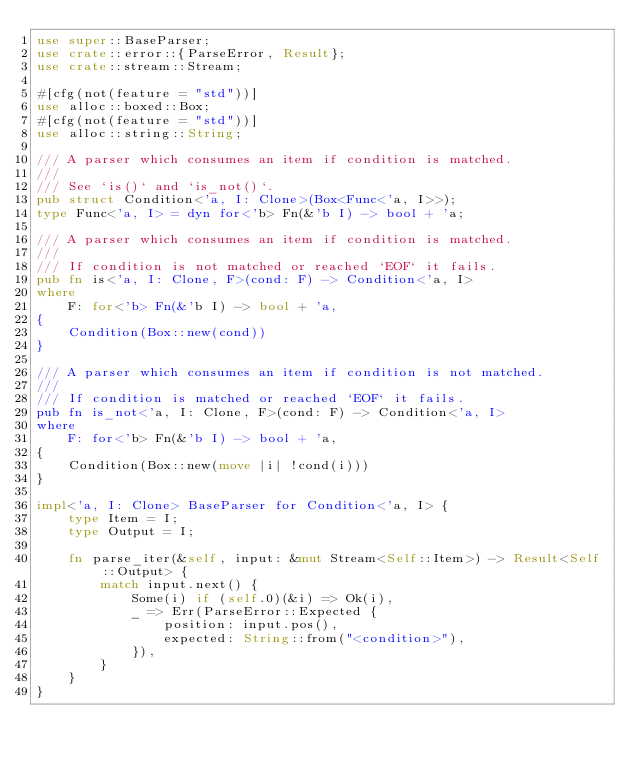Convert code to text. <code><loc_0><loc_0><loc_500><loc_500><_Rust_>use super::BaseParser;
use crate::error::{ParseError, Result};
use crate::stream::Stream;

#[cfg(not(feature = "std"))]
use alloc::boxed::Box;
#[cfg(not(feature = "std"))]
use alloc::string::String;

/// A parser which consumes an item if condition is matched.
///
/// See `is()` and `is_not()`.
pub struct Condition<'a, I: Clone>(Box<Func<'a, I>>);
type Func<'a, I> = dyn for<'b> Fn(&'b I) -> bool + 'a;

/// A parser which consumes an item if condition is matched.
///
/// If condition is not matched or reached `EOF` it fails.
pub fn is<'a, I: Clone, F>(cond: F) -> Condition<'a, I>
where
    F: for<'b> Fn(&'b I) -> bool + 'a,
{
    Condition(Box::new(cond))
}

/// A parser which consumes an item if condition is not matched.
///
/// If condition is matched or reached `EOF` it fails.
pub fn is_not<'a, I: Clone, F>(cond: F) -> Condition<'a, I>
where
    F: for<'b> Fn(&'b I) -> bool + 'a,
{
    Condition(Box::new(move |i| !cond(i)))
}

impl<'a, I: Clone> BaseParser for Condition<'a, I> {
    type Item = I;
    type Output = I;

    fn parse_iter(&self, input: &mut Stream<Self::Item>) -> Result<Self::Output> {
        match input.next() {
            Some(i) if (self.0)(&i) => Ok(i),
            _ => Err(ParseError::Expected {
                position: input.pos(),
                expected: String::from("<condition>"),
            }),
        }
    }
}
</code> 